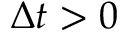<formula> <loc_0><loc_0><loc_500><loc_500>\Delta t > 0</formula> 